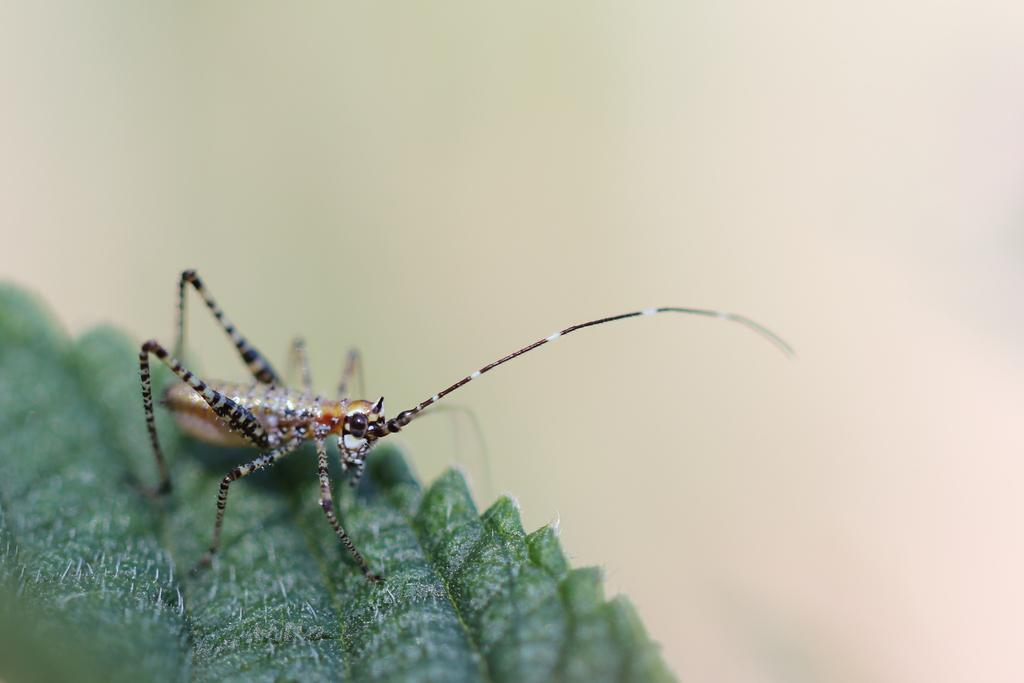What is the main subject of the picture? The main subject of the picture is an insect. Where is the insect located? The insect is on a leaf. Can you describe the background of the image? The background of the image is blurry. What type of dirt can be seen on the desk in the image? There is no desk present in the image, and therefore no dirt on a desk can be observed. 